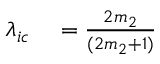Convert formula to latex. <formula><loc_0><loc_0><loc_500><loc_500>\begin{array} { r l } { \lambda _ { i c } } & = \frac { 2 m _ { 2 } } { ( 2 m _ { 2 } + 1 ) } } \end{array}</formula> 